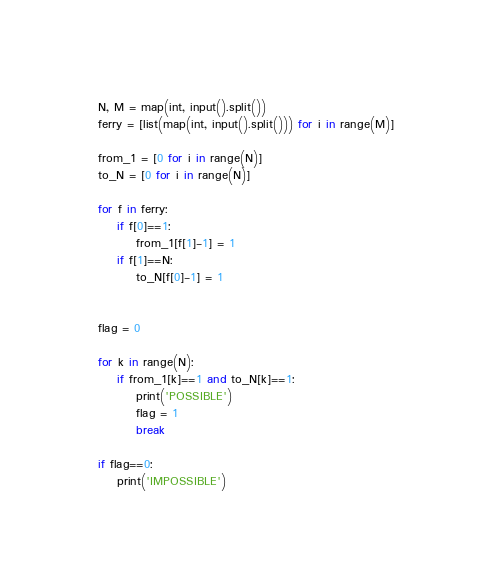Convert code to text. <code><loc_0><loc_0><loc_500><loc_500><_Python_>N, M = map(int, input().split())
ferry = [list(map(int, input().split())) for i in range(M)]

from_1 = [0 for i in range(N)]
to_N = [0 for i in range(N)]

for f in ferry:
    if f[0]==1:
        from_1[f[1]-1] = 1
    if f[1]==N:
        to_N[f[0]-1] = 1


flag = 0

for k in range(N):
    if from_1[k]==1 and to_N[k]==1:
        print('POSSIBLE')
        flag = 1
        break

if flag==0:
    print('IMPOSSIBLE')
</code> 